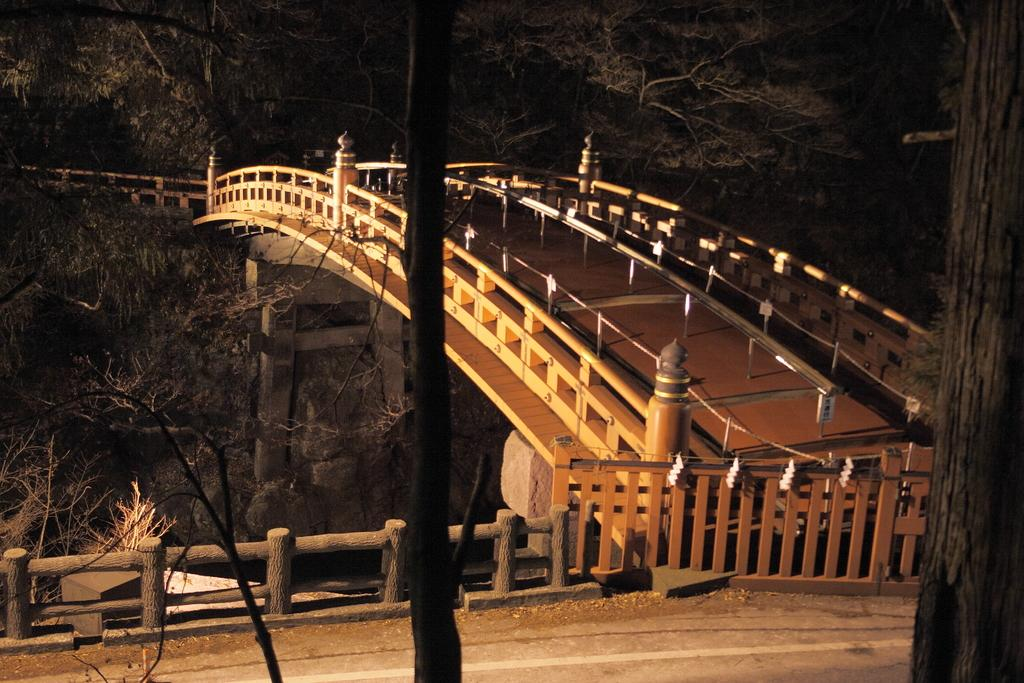What structure is located in the middle of the image? There is a bridge in the middle of the image. What type of vegetation can be seen at the top of the image? There are trees at the top of the image. What else can be seen in the middle of the image besides the bridge? There are trees in the middle of the image. What type of jeans is the zebra wearing on its trip in the image? There is no zebra or jeans present in the image. 